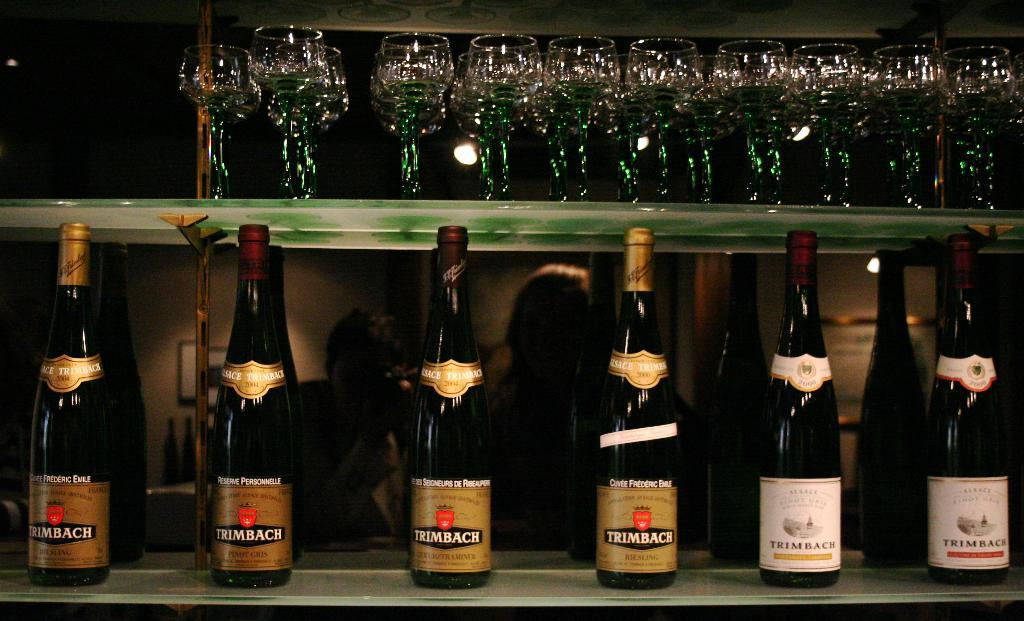What type of furniture is present in the image? There is a table in the image. What items can be seen on the table? There are different bottles on the table. What is located above the table? There is a shelf above the table. How are the glasses arranged on the shelf? Many glasses are kept in a row on the shelf. What type of game is being played on the table in the image? There is no game being played on the table in the image; it only shows different bottles and a shelf with glasses. 